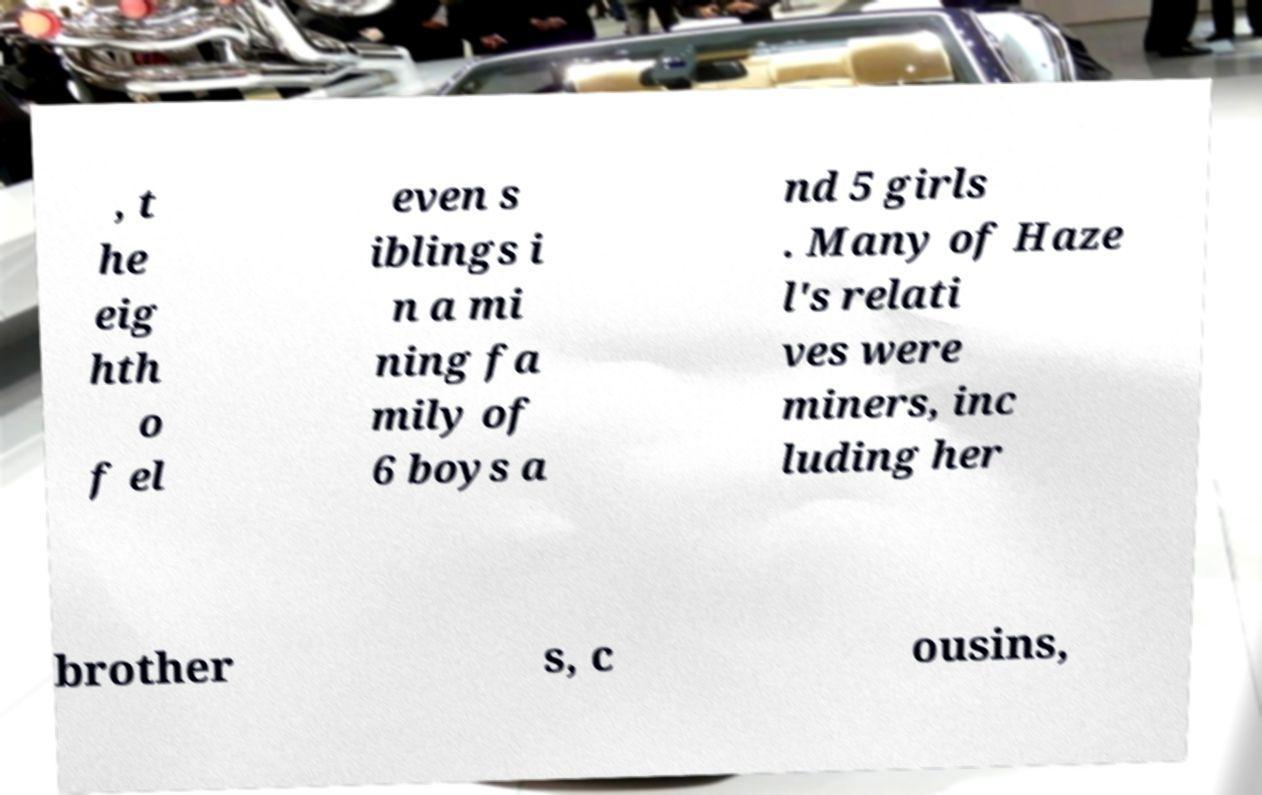Please read and relay the text visible in this image. What does it say? , t he eig hth o f el even s iblings i n a mi ning fa mily of 6 boys a nd 5 girls . Many of Haze l's relati ves were miners, inc luding her brother s, c ousins, 